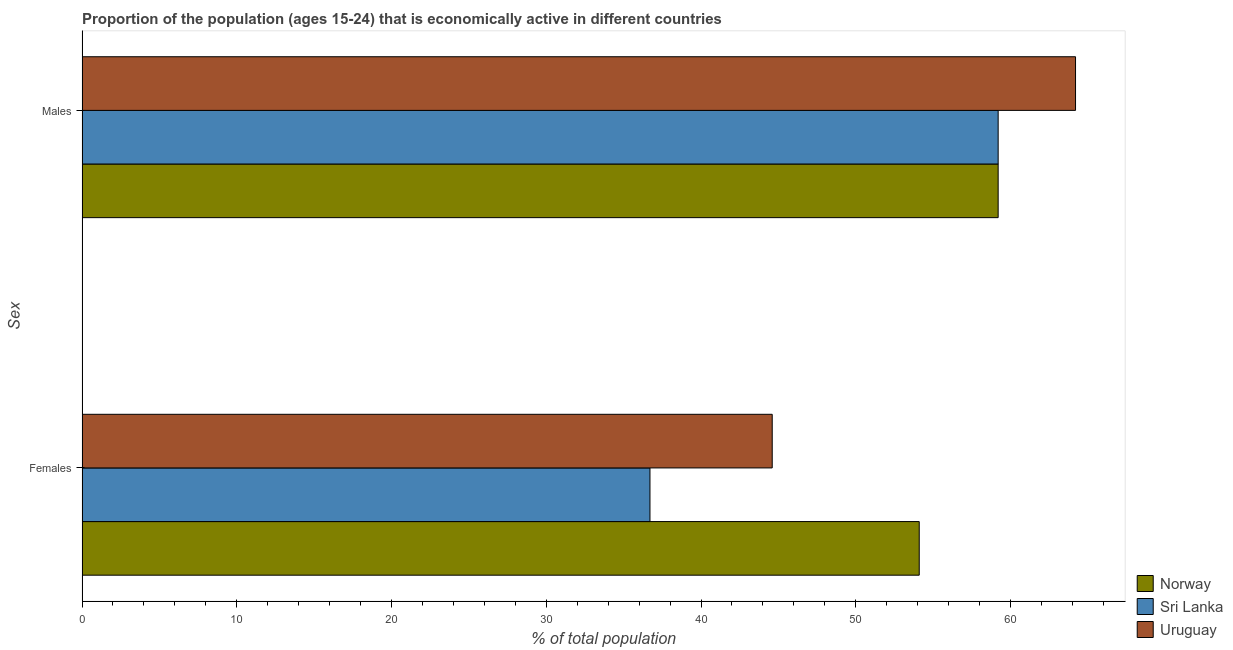How many different coloured bars are there?
Provide a short and direct response. 3. What is the label of the 1st group of bars from the top?
Provide a succinct answer. Males. What is the percentage of economically active female population in Norway?
Make the answer very short. 54.1. Across all countries, what is the maximum percentage of economically active male population?
Ensure brevity in your answer.  64.2. Across all countries, what is the minimum percentage of economically active female population?
Your answer should be very brief. 36.7. In which country was the percentage of economically active female population maximum?
Provide a short and direct response. Norway. In which country was the percentage of economically active female population minimum?
Offer a terse response. Sri Lanka. What is the total percentage of economically active male population in the graph?
Your answer should be compact. 182.6. What is the difference between the percentage of economically active male population in Sri Lanka and that in Uruguay?
Provide a succinct answer. -5. What is the difference between the percentage of economically active male population in Sri Lanka and the percentage of economically active female population in Uruguay?
Provide a short and direct response. 14.6. What is the average percentage of economically active female population per country?
Make the answer very short. 45.13. What is the difference between the percentage of economically active male population and percentage of economically active female population in Uruguay?
Keep it short and to the point. 19.6. In how many countries, is the percentage of economically active female population greater than 46 %?
Offer a very short reply. 1. What is the ratio of the percentage of economically active male population in Sri Lanka to that in Norway?
Offer a terse response. 1. Is the percentage of economically active female population in Norway less than that in Uruguay?
Your answer should be compact. No. What does the 1st bar from the top in Females represents?
Offer a terse response. Uruguay. What does the 3rd bar from the bottom in Males represents?
Your answer should be compact. Uruguay. Are all the bars in the graph horizontal?
Provide a succinct answer. Yes. How many countries are there in the graph?
Provide a short and direct response. 3. What is the difference between two consecutive major ticks on the X-axis?
Provide a short and direct response. 10. Are the values on the major ticks of X-axis written in scientific E-notation?
Your answer should be compact. No. Does the graph contain any zero values?
Give a very brief answer. No. Does the graph contain grids?
Your answer should be very brief. No. What is the title of the graph?
Provide a short and direct response. Proportion of the population (ages 15-24) that is economically active in different countries. Does "Botswana" appear as one of the legend labels in the graph?
Provide a short and direct response. No. What is the label or title of the X-axis?
Give a very brief answer. % of total population. What is the label or title of the Y-axis?
Offer a terse response. Sex. What is the % of total population in Norway in Females?
Your response must be concise. 54.1. What is the % of total population of Sri Lanka in Females?
Provide a short and direct response. 36.7. What is the % of total population in Uruguay in Females?
Keep it short and to the point. 44.6. What is the % of total population of Norway in Males?
Keep it short and to the point. 59.2. What is the % of total population of Sri Lanka in Males?
Provide a short and direct response. 59.2. What is the % of total population of Uruguay in Males?
Offer a very short reply. 64.2. Across all Sex, what is the maximum % of total population in Norway?
Ensure brevity in your answer.  59.2. Across all Sex, what is the maximum % of total population of Sri Lanka?
Offer a terse response. 59.2. Across all Sex, what is the maximum % of total population in Uruguay?
Your answer should be compact. 64.2. Across all Sex, what is the minimum % of total population in Norway?
Keep it short and to the point. 54.1. Across all Sex, what is the minimum % of total population of Sri Lanka?
Your response must be concise. 36.7. Across all Sex, what is the minimum % of total population of Uruguay?
Ensure brevity in your answer.  44.6. What is the total % of total population of Norway in the graph?
Provide a succinct answer. 113.3. What is the total % of total population in Sri Lanka in the graph?
Keep it short and to the point. 95.9. What is the total % of total population of Uruguay in the graph?
Your response must be concise. 108.8. What is the difference between the % of total population of Sri Lanka in Females and that in Males?
Offer a very short reply. -22.5. What is the difference between the % of total population in Uruguay in Females and that in Males?
Your answer should be compact. -19.6. What is the difference between the % of total population of Norway in Females and the % of total population of Sri Lanka in Males?
Your response must be concise. -5.1. What is the difference between the % of total population in Sri Lanka in Females and the % of total population in Uruguay in Males?
Your response must be concise. -27.5. What is the average % of total population of Norway per Sex?
Your response must be concise. 56.65. What is the average % of total population of Sri Lanka per Sex?
Make the answer very short. 47.95. What is the average % of total population in Uruguay per Sex?
Provide a short and direct response. 54.4. What is the difference between the % of total population in Norway and % of total population in Sri Lanka in Females?
Offer a very short reply. 17.4. What is the difference between the % of total population in Norway and % of total population in Uruguay in Females?
Make the answer very short. 9.5. What is the ratio of the % of total population of Norway in Females to that in Males?
Make the answer very short. 0.91. What is the ratio of the % of total population in Sri Lanka in Females to that in Males?
Offer a terse response. 0.62. What is the ratio of the % of total population in Uruguay in Females to that in Males?
Provide a succinct answer. 0.69. What is the difference between the highest and the second highest % of total population in Norway?
Provide a succinct answer. 5.1. What is the difference between the highest and the second highest % of total population in Uruguay?
Make the answer very short. 19.6. What is the difference between the highest and the lowest % of total population in Norway?
Provide a succinct answer. 5.1. What is the difference between the highest and the lowest % of total population of Uruguay?
Provide a short and direct response. 19.6. 